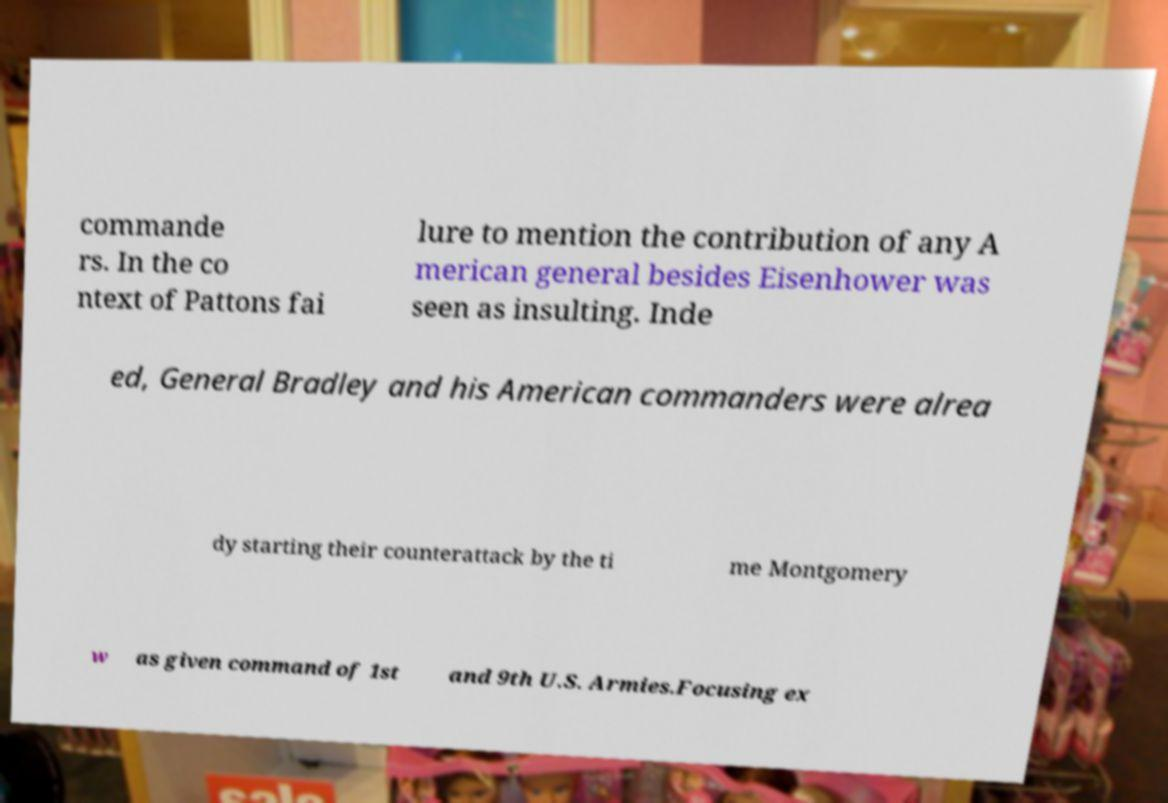Could you assist in decoding the text presented in this image and type it out clearly? commande rs. In the co ntext of Pattons fai lure to mention the contribution of any A merican general besides Eisenhower was seen as insulting. Inde ed, General Bradley and his American commanders were alrea dy starting their counterattack by the ti me Montgomery w as given command of 1st and 9th U.S. Armies.Focusing ex 